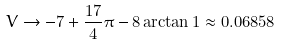Convert formula to latex. <formula><loc_0><loc_0><loc_500><loc_500>V \to - 7 + \frac { 1 7 } { 4 } \pi - 8 \arctan 1 \approx 0 . 0 6 8 5 8</formula> 